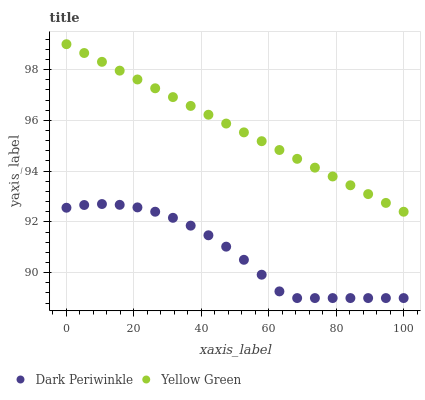Does Dark Periwinkle have the minimum area under the curve?
Answer yes or no. Yes. Does Yellow Green have the maximum area under the curve?
Answer yes or no. Yes. Does Yellow Green have the minimum area under the curve?
Answer yes or no. No. Is Yellow Green the smoothest?
Answer yes or no. Yes. Is Dark Periwinkle the roughest?
Answer yes or no. Yes. Is Yellow Green the roughest?
Answer yes or no. No. Does Dark Periwinkle have the lowest value?
Answer yes or no. Yes. Does Yellow Green have the lowest value?
Answer yes or no. No. Does Yellow Green have the highest value?
Answer yes or no. Yes. Is Dark Periwinkle less than Yellow Green?
Answer yes or no. Yes. Is Yellow Green greater than Dark Periwinkle?
Answer yes or no. Yes. Does Dark Periwinkle intersect Yellow Green?
Answer yes or no. No. 